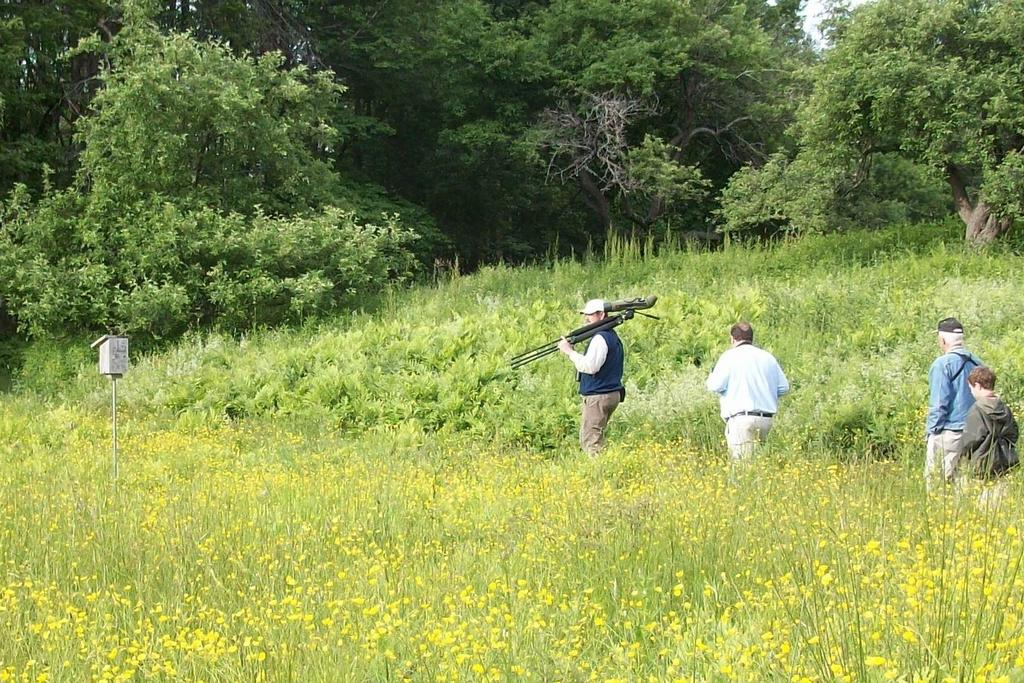What are the people in the image doing? The people in the image are walking. What type of vegetation can be seen in the image? There are plants and trees in the image. What object is the man holding in his hand? The man is holding a tripod in his hand. Can you describe the small object on a pole in the image? There is a small box on a pole in the image. How many clocks are hanging on the trees in the image? There are no clocks hanging on the trees in the image. What type of alley can be seen in the image? There is no alley present in the image. 